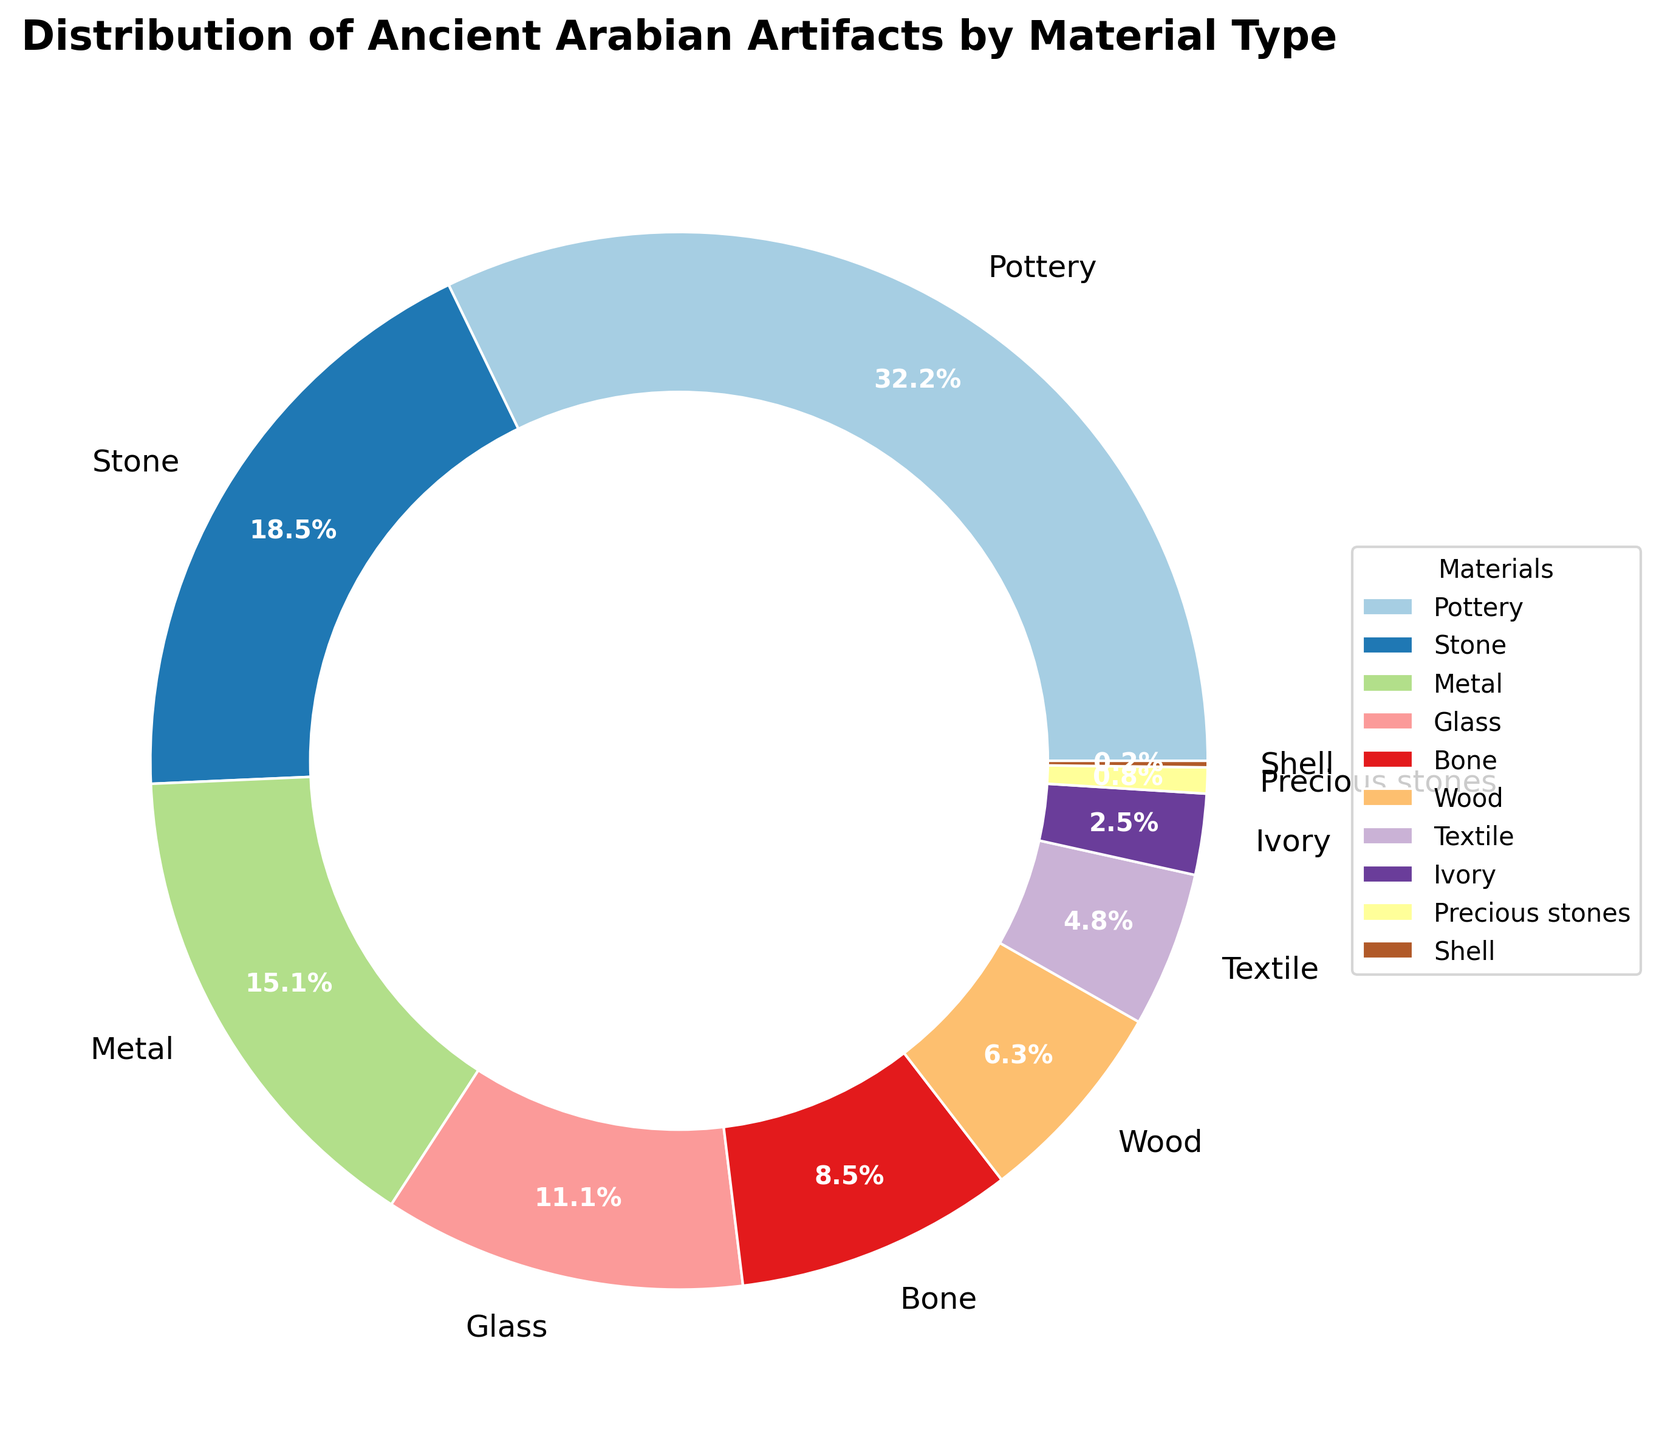What's the most common material used for ancient Arabian artifacts? The largest segment of the pie chart represents Pottery, suggesting it is the most common material among the artifacts shown.
Answer: Pottery Which material is the second most common? The second largest segment of the pie chart corresponds to Stone, indicating it is the second most common material.
Answer: Stone Are there more artifacts made of Metal or Glass? By comparing the sizes of the pie chart segments, the Metal segment is larger than the Glass segment.
Answer: Metal What is the combined percentage of artifacts made from Wood and Bone? The Wood segment has a percentage of 6.4% and the Bone segment has a percentage of 8.6%. Summing these percentages: 6.4% + 8.6% = 15%.
Answer: 15% How does the percentage of artifacts made from Textile compare to that of Ivory? The pie chart shows that Textile has a larger segment than Ivory. Specifically, Textile is 4.8% while Ivory is 2.5%.
Answer: Textile is larger What is the total percentage of artifacts made from either Precious stones or Shell? Precious stones make up 0.8% of the artifacts while Shell makes up 0.2%. Adding these: 0.8% + 0.2% = 1%.
Answer: 1% Which material represents less than 1% of the artifacts? The pie chart segment for Shell is the smallest and corresponds to 0.2%.
Answer: Shell What is the difference in percentage points between the most and least common materials? The most common material, Pottery, is 32.5%, and the least common material, Shell, is 0.2%. The difference is calculated as 32.5% - 0.2% = 32.3%.
Answer: 32.3% How does the percentage of Stone artifacts compare to that of Metal and Glass combined? Stone has a percentage of 18.7%. Metal and Glass combined have percentages of 15.3% and 11.2%, respectively. Summing Metal and Glass: 15.3% + 11.2% = 26.5%. Therefore, Stone (18.7%) is less than Metal and Glass combined (26.5%).
Answer: Less What colors represent the segments for Glass and Metal? The pie chart uses a color palette to distinguish segments. By examining the chart, the segment for Glass is shown in a distinct color different from the segment for Metal. The colors are visually distinguishable but specific colors are not named in the data provided.
Answer: Distinct colors 